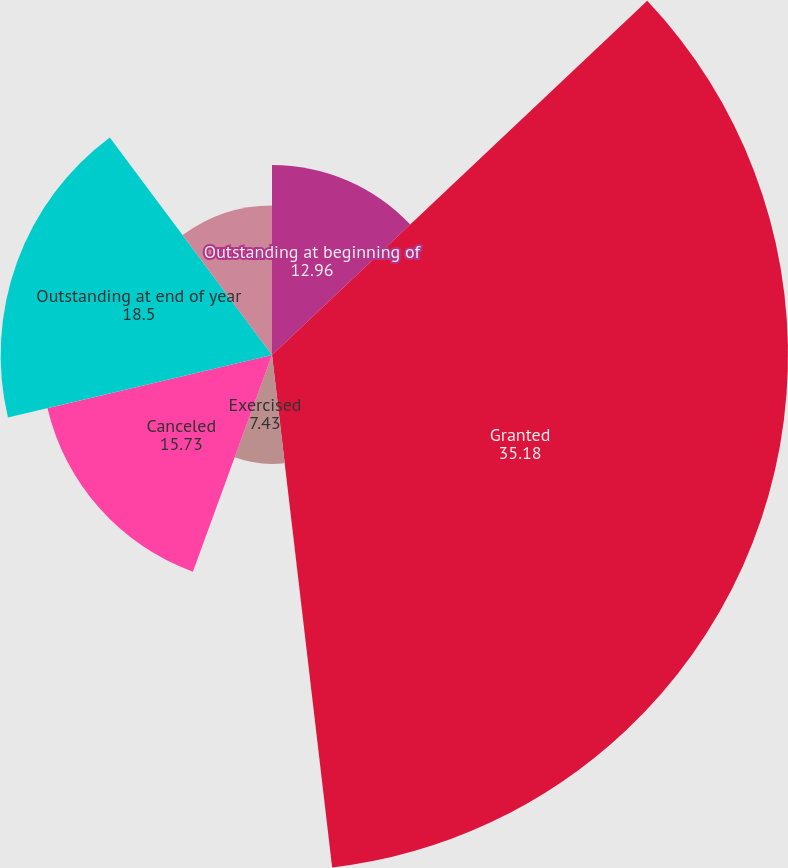<chart> <loc_0><loc_0><loc_500><loc_500><pie_chart><fcel>Outstanding at beginning of<fcel>Granted<fcel>Exercised<fcel>Canceled<fcel>Outstanding at end of year<fcel>Exercisable at end of year<nl><fcel>12.96%<fcel>35.18%<fcel>7.43%<fcel>15.73%<fcel>18.5%<fcel>10.2%<nl></chart> 